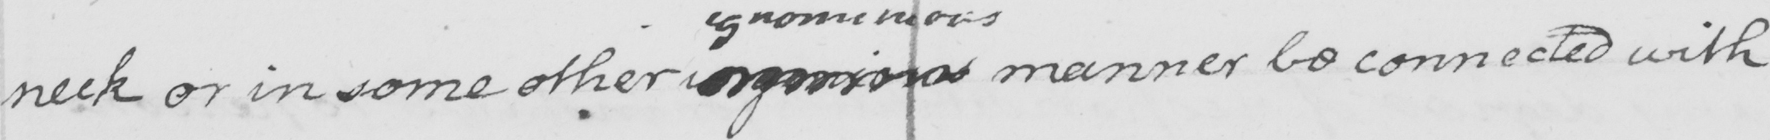What is written in this line of handwriting? neck or in some other  <gap/>  manner be connected with 